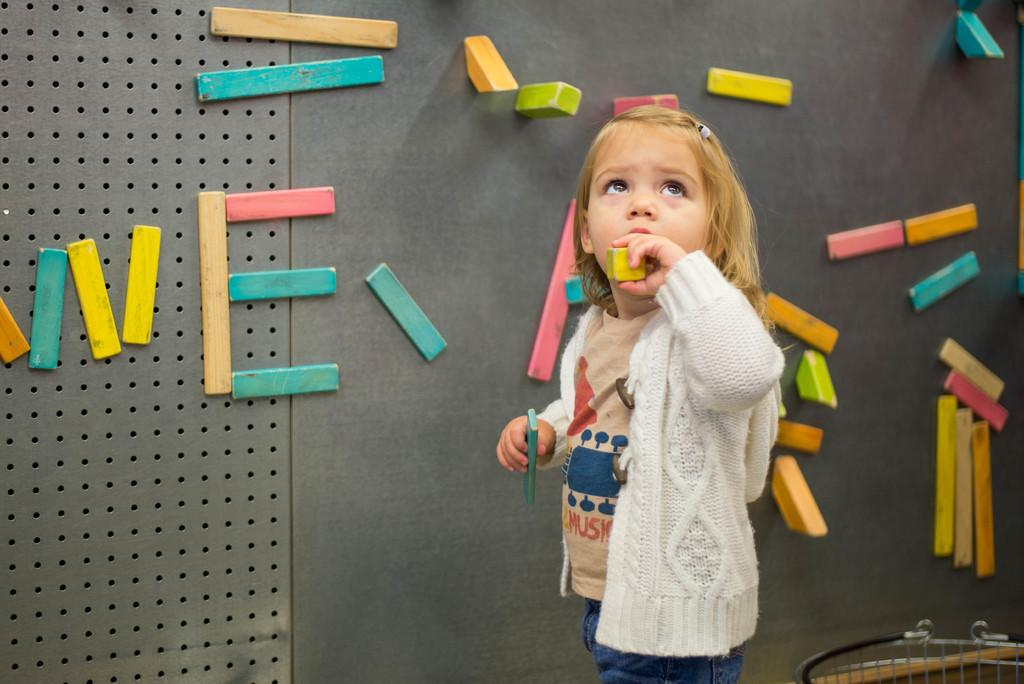What is the main subject of the image? There is a girl standing in the image. What is the girl holding in her hands? The girl is holding two objects in her hands. What can be seen behind the girl? There is a wall behind the girl. What is on the wall? There are wooden blocks stacked on the wall. Can you tell me how many times the girl's brother shakes the oven in the image? There is no brother or oven present in the image, so this question cannot be answered. 